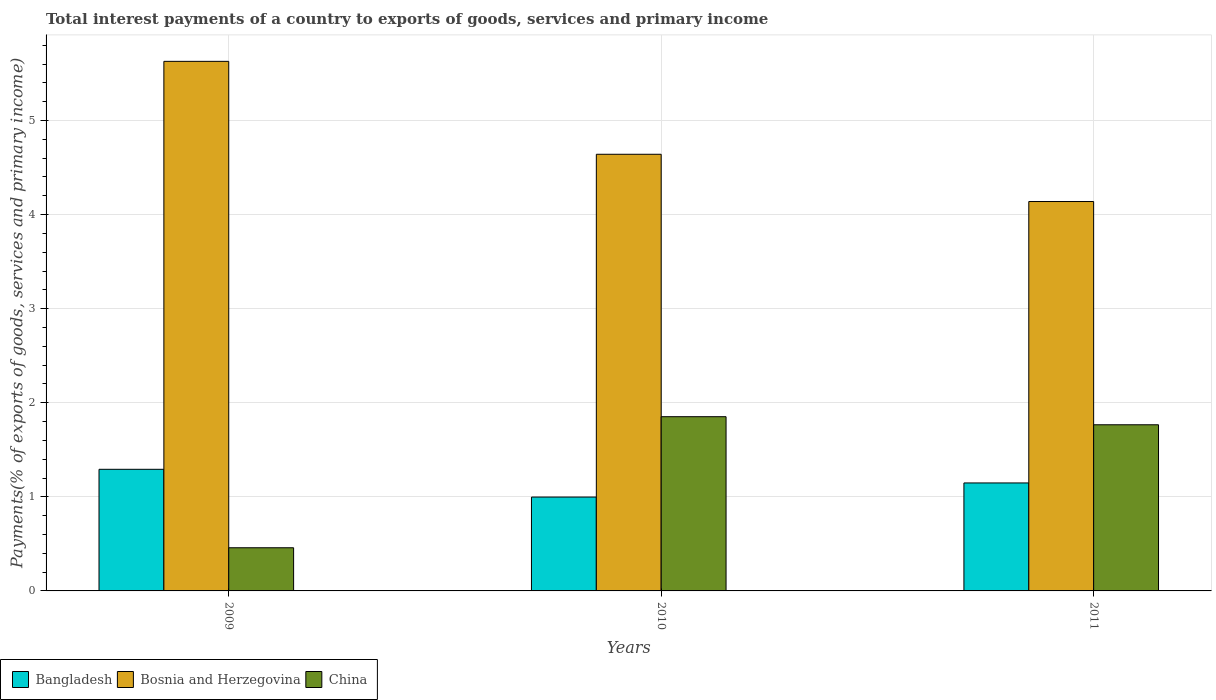Are the number of bars per tick equal to the number of legend labels?
Keep it short and to the point. Yes. How many bars are there on the 3rd tick from the left?
Make the answer very short. 3. In how many cases, is the number of bars for a given year not equal to the number of legend labels?
Your response must be concise. 0. What is the total interest payments in Bangladesh in 2010?
Offer a terse response. 1. Across all years, what is the maximum total interest payments in China?
Your answer should be very brief. 1.85. Across all years, what is the minimum total interest payments in China?
Your answer should be compact. 0.46. In which year was the total interest payments in Bangladesh maximum?
Offer a very short reply. 2009. What is the total total interest payments in Bosnia and Herzegovina in the graph?
Offer a terse response. 14.41. What is the difference between the total interest payments in Bosnia and Herzegovina in 2009 and that in 2011?
Your answer should be very brief. 1.49. What is the difference between the total interest payments in China in 2011 and the total interest payments in Bosnia and Herzegovina in 2010?
Your answer should be very brief. -2.88. What is the average total interest payments in China per year?
Your response must be concise. 1.36. In the year 2009, what is the difference between the total interest payments in Bosnia and Herzegovina and total interest payments in Bangladesh?
Offer a very short reply. 4.34. In how many years, is the total interest payments in China greater than 1 %?
Ensure brevity in your answer.  2. What is the ratio of the total interest payments in Bangladesh in 2009 to that in 2010?
Give a very brief answer. 1.3. Is the difference between the total interest payments in Bosnia and Herzegovina in 2009 and 2011 greater than the difference between the total interest payments in Bangladesh in 2009 and 2011?
Keep it short and to the point. Yes. What is the difference between the highest and the second highest total interest payments in China?
Your response must be concise. 0.09. What is the difference between the highest and the lowest total interest payments in China?
Make the answer very short. 1.39. What does the 2nd bar from the left in 2010 represents?
Keep it short and to the point. Bosnia and Herzegovina. What does the 2nd bar from the right in 2010 represents?
Give a very brief answer. Bosnia and Herzegovina. Is it the case that in every year, the sum of the total interest payments in Bangladesh and total interest payments in China is greater than the total interest payments in Bosnia and Herzegovina?
Offer a very short reply. No. How many bars are there?
Offer a very short reply. 9. Are all the bars in the graph horizontal?
Provide a short and direct response. No. What is the difference between two consecutive major ticks on the Y-axis?
Ensure brevity in your answer.  1. Where does the legend appear in the graph?
Your response must be concise. Bottom left. What is the title of the graph?
Keep it short and to the point. Total interest payments of a country to exports of goods, services and primary income. What is the label or title of the Y-axis?
Keep it short and to the point. Payments(% of exports of goods, services and primary income). What is the Payments(% of exports of goods, services and primary income) of Bangladesh in 2009?
Offer a terse response. 1.29. What is the Payments(% of exports of goods, services and primary income) of Bosnia and Herzegovina in 2009?
Ensure brevity in your answer.  5.63. What is the Payments(% of exports of goods, services and primary income) of China in 2009?
Offer a very short reply. 0.46. What is the Payments(% of exports of goods, services and primary income) in Bangladesh in 2010?
Offer a very short reply. 1. What is the Payments(% of exports of goods, services and primary income) of Bosnia and Herzegovina in 2010?
Give a very brief answer. 4.64. What is the Payments(% of exports of goods, services and primary income) of China in 2010?
Your answer should be very brief. 1.85. What is the Payments(% of exports of goods, services and primary income) in Bangladesh in 2011?
Provide a short and direct response. 1.15. What is the Payments(% of exports of goods, services and primary income) in Bosnia and Herzegovina in 2011?
Make the answer very short. 4.14. What is the Payments(% of exports of goods, services and primary income) of China in 2011?
Provide a short and direct response. 1.77. Across all years, what is the maximum Payments(% of exports of goods, services and primary income) in Bangladesh?
Ensure brevity in your answer.  1.29. Across all years, what is the maximum Payments(% of exports of goods, services and primary income) of Bosnia and Herzegovina?
Give a very brief answer. 5.63. Across all years, what is the maximum Payments(% of exports of goods, services and primary income) in China?
Ensure brevity in your answer.  1.85. Across all years, what is the minimum Payments(% of exports of goods, services and primary income) of Bangladesh?
Make the answer very short. 1. Across all years, what is the minimum Payments(% of exports of goods, services and primary income) in Bosnia and Herzegovina?
Make the answer very short. 4.14. Across all years, what is the minimum Payments(% of exports of goods, services and primary income) in China?
Provide a short and direct response. 0.46. What is the total Payments(% of exports of goods, services and primary income) in Bangladesh in the graph?
Give a very brief answer. 3.44. What is the total Payments(% of exports of goods, services and primary income) in Bosnia and Herzegovina in the graph?
Your response must be concise. 14.41. What is the total Payments(% of exports of goods, services and primary income) of China in the graph?
Ensure brevity in your answer.  4.08. What is the difference between the Payments(% of exports of goods, services and primary income) of Bangladesh in 2009 and that in 2010?
Keep it short and to the point. 0.29. What is the difference between the Payments(% of exports of goods, services and primary income) in Bosnia and Herzegovina in 2009 and that in 2010?
Provide a succinct answer. 0.99. What is the difference between the Payments(% of exports of goods, services and primary income) in China in 2009 and that in 2010?
Offer a very short reply. -1.39. What is the difference between the Payments(% of exports of goods, services and primary income) of Bangladesh in 2009 and that in 2011?
Keep it short and to the point. 0.14. What is the difference between the Payments(% of exports of goods, services and primary income) in Bosnia and Herzegovina in 2009 and that in 2011?
Make the answer very short. 1.49. What is the difference between the Payments(% of exports of goods, services and primary income) of China in 2009 and that in 2011?
Offer a terse response. -1.31. What is the difference between the Payments(% of exports of goods, services and primary income) of Bangladesh in 2010 and that in 2011?
Offer a terse response. -0.15. What is the difference between the Payments(% of exports of goods, services and primary income) of Bosnia and Herzegovina in 2010 and that in 2011?
Give a very brief answer. 0.5. What is the difference between the Payments(% of exports of goods, services and primary income) of China in 2010 and that in 2011?
Ensure brevity in your answer.  0.09. What is the difference between the Payments(% of exports of goods, services and primary income) in Bangladesh in 2009 and the Payments(% of exports of goods, services and primary income) in Bosnia and Herzegovina in 2010?
Your answer should be compact. -3.35. What is the difference between the Payments(% of exports of goods, services and primary income) in Bangladesh in 2009 and the Payments(% of exports of goods, services and primary income) in China in 2010?
Your response must be concise. -0.56. What is the difference between the Payments(% of exports of goods, services and primary income) of Bosnia and Herzegovina in 2009 and the Payments(% of exports of goods, services and primary income) of China in 2010?
Keep it short and to the point. 3.78. What is the difference between the Payments(% of exports of goods, services and primary income) of Bangladesh in 2009 and the Payments(% of exports of goods, services and primary income) of Bosnia and Herzegovina in 2011?
Make the answer very short. -2.85. What is the difference between the Payments(% of exports of goods, services and primary income) of Bangladesh in 2009 and the Payments(% of exports of goods, services and primary income) of China in 2011?
Provide a short and direct response. -0.47. What is the difference between the Payments(% of exports of goods, services and primary income) in Bosnia and Herzegovina in 2009 and the Payments(% of exports of goods, services and primary income) in China in 2011?
Your answer should be compact. 3.86. What is the difference between the Payments(% of exports of goods, services and primary income) of Bangladesh in 2010 and the Payments(% of exports of goods, services and primary income) of Bosnia and Herzegovina in 2011?
Offer a very short reply. -3.14. What is the difference between the Payments(% of exports of goods, services and primary income) in Bangladesh in 2010 and the Payments(% of exports of goods, services and primary income) in China in 2011?
Your response must be concise. -0.77. What is the difference between the Payments(% of exports of goods, services and primary income) in Bosnia and Herzegovina in 2010 and the Payments(% of exports of goods, services and primary income) in China in 2011?
Offer a very short reply. 2.88. What is the average Payments(% of exports of goods, services and primary income) in Bangladesh per year?
Keep it short and to the point. 1.15. What is the average Payments(% of exports of goods, services and primary income) in Bosnia and Herzegovina per year?
Provide a short and direct response. 4.8. What is the average Payments(% of exports of goods, services and primary income) in China per year?
Ensure brevity in your answer.  1.36. In the year 2009, what is the difference between the Payments(% of exports of goods, services and primary income) of Bangladesh and Payments(% of exports of goods, services and primary income) of Bosnia and Herzegovina?
Keep it short and to the point. -4.34. In the year 2009, what is the difference between the Payments(% of exports of goods, services and primary income) in Bangladesh and Payments(% of exports of goods, services and primary income) in China?
Make the answer very short. 0.83. In the year 2009, what is the difference between the Payments(% of exports of goods, services and primary income) in Bosnia and Herzegovina and Payments(% of exports of goods, services and primary income) in China?
Your answer should be compact. 5.17. In the year 2010, what is the difference between the Payments(% of exports of goods, services and primary income) of Bangladesh and Payments(% of exports of goods, services and primary income) of Bosnia and Herzegovina?
Your answer should be compact. -3.64. In the year 2010, what is the difference between the Payments(% of exports of goods, services and primary income) of Bangladesh and Payments(% of exports of goods, services and primary income) of China?
Provide a short and direct response. -0.85. In the year 2010, what is the difference between the Payments(% of exports of goods, services and primary income) in Bosnia and Herzegovina and Payments(% of exports of goods, services and primary income) in China?
Make the answer very short. 2.79. In the year 2011, what is the difference between the Payments(% of exports of goods, services and primary income) of Bangladesh and Payments(% of exports of goods, services and primary income) of Bosnia and Herzegovina?
Your answer should be very brief. -2.99. In the year 2011, what is the difference between the Payments(% of exports of goods, services and primary income) in Bangladesh and Payments(% of exports of goods, services and primary income) in China?
Ensure brevity in your answer.  -0.62. In the year 2011, what is the difference between the Payments(% of exports of goods, services and primary income) of Bosnia and Herzegovina and Payments(% of exports of goods, services and primary income) of China?
Give a very brief answer. 2.37. What is the ratio of the Payments(% of exports of goods, services and primary income) in Bangladesh in 2009 to that in 2010?
Provide a short and direct response. 1.3. What is the ratio of the Payments(% of exports of goods, services and primary income) of Bosnia and Herzegovina in 2009 to that in 2010?
Your response must be concise. 1.21. What is the ratio of the Payments(% of exports of goods, services and primary income) of China in 2009 to that in 2010?
Offer a terse response. 0.25. What is the ratio of the Payments(% of exports of goods, services and primary income) in Bangladesh in 2009 to that in 2011?
Offer a very short reply. 1.13. What is the ratio of the Payments(% of exports of goods, services and primary income) in Bosnia and Herzegovina in 2009 to that in 2011?
Make the answer very short. 1.36. What is the ratio of the Payments(% of exports of goods, services and primary income) of China in 2009 to that in 2011?
Give a very brief answer. 0.26. What is the ratio of the Payments(% of exports of goods, services and primary income) of Bangladesh in 2010 to that in 2011?
Give a very brief answer. 0.87. What is the ratio of the Payments(% of exports of goods, services and primary income) of Bosnia and Herzegovina in 2010 to that in 2011?
Make the answer very short. 1.12. What is the ratio of the Payments(% of exports of goods, services and primary income) in China in 2010 to that in 2011?
Offer a terse response. 1.05. What is the difference between the highest and the second highest Payments(% of exports of goods, services and primary income) in Bangladesh?
Provide a short and direct response. 0.14. What is the difference between the highest and the second highest Payments(% of exports of goods, services and primary income) in Bosnia and Herzegovina?
Offer a terse response. 0.99. What is the difference between the highest and the second highest Payments(% of exports of goods, services and primary income) of China?
Provide a succinct answer. 0.09. What is the difference between the highest and the lowest Payments(% of exports of goods, services and primary income) in Bangladesh?
Ensure brevity in your answer.  0.29. What is the difference between the highest and the lowest Payments(% of exports of goods, services and primary income) in Bosnia and Herzegovina?
Make the answer very short. 1.49. What is the difference between the highest and the lowest Payments(% of exports of goods, services and primary income) in China?
Offer a very short reply. 1.39. 